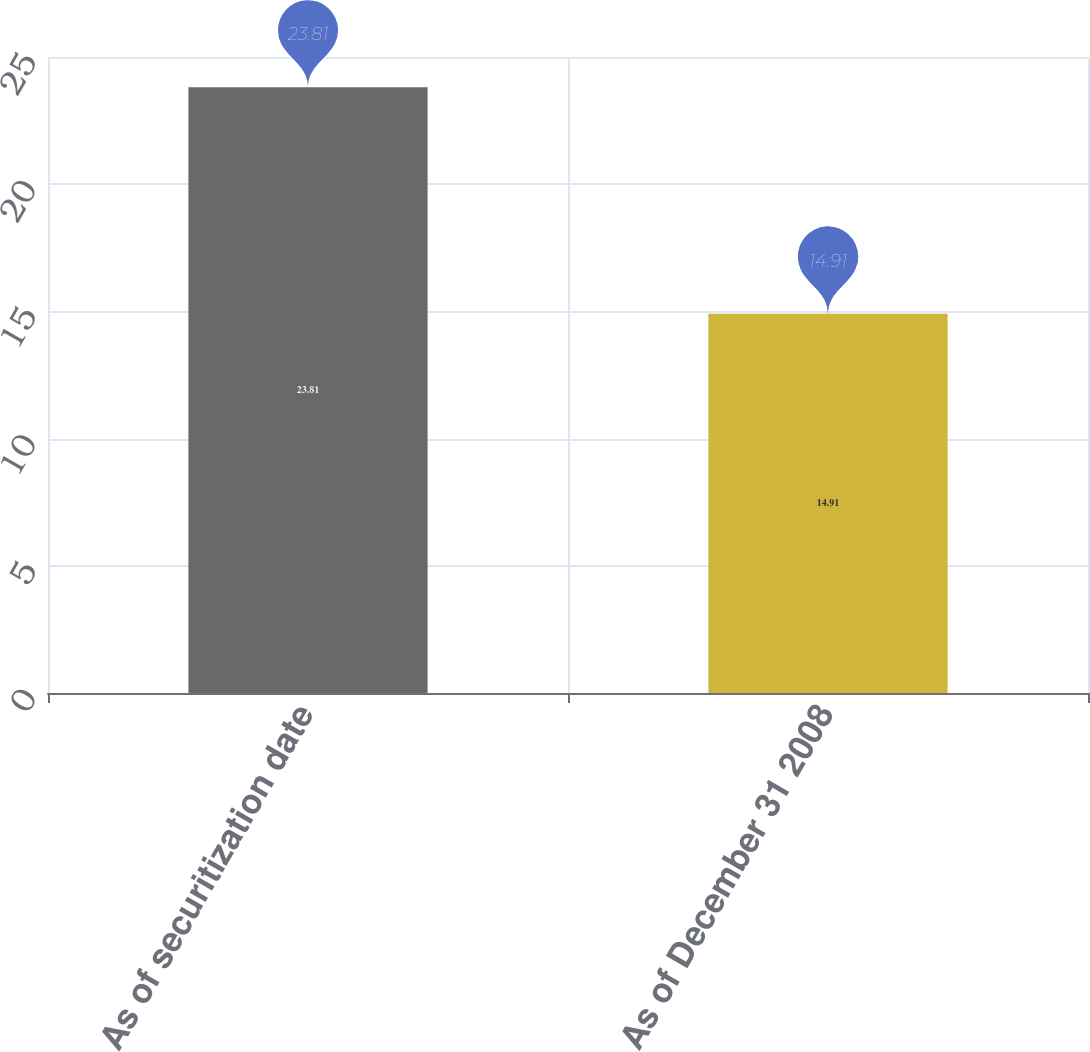Convert chart. <chart><loc_0><loc_0><loc_500><loc_500><bar_chart><fcel>As of securitization date<fcel>As of December 31 2008<nl><fcel>23.81<fcel>14.91<nl></chart> 